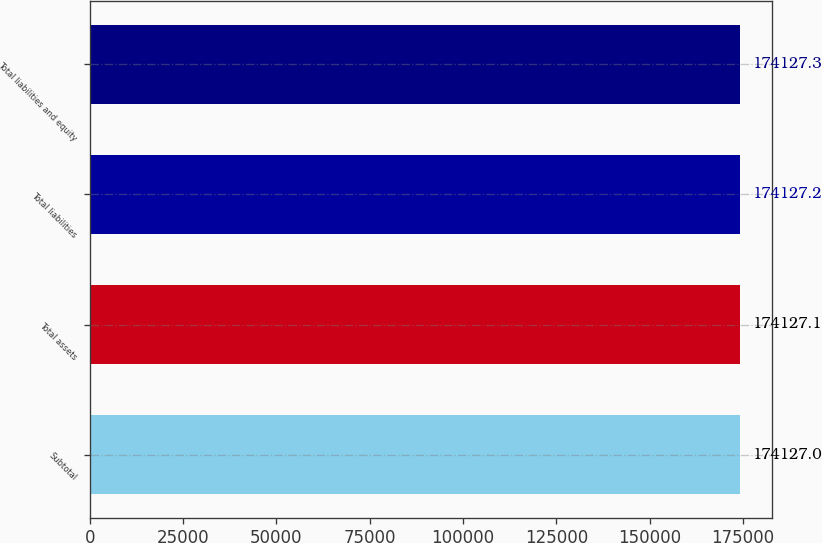Convert chart to OTSL. <chart><loc_0><loc_0><loc_500><loc_500><bar_chart><fcel>Subtotal<fcel>Total assets<fcel>Total liabilities<fcel>Total liabilities and equity<nl><fcel>174127<fcel>174127<fcel>174127<fcel>174127<nl></chart> 